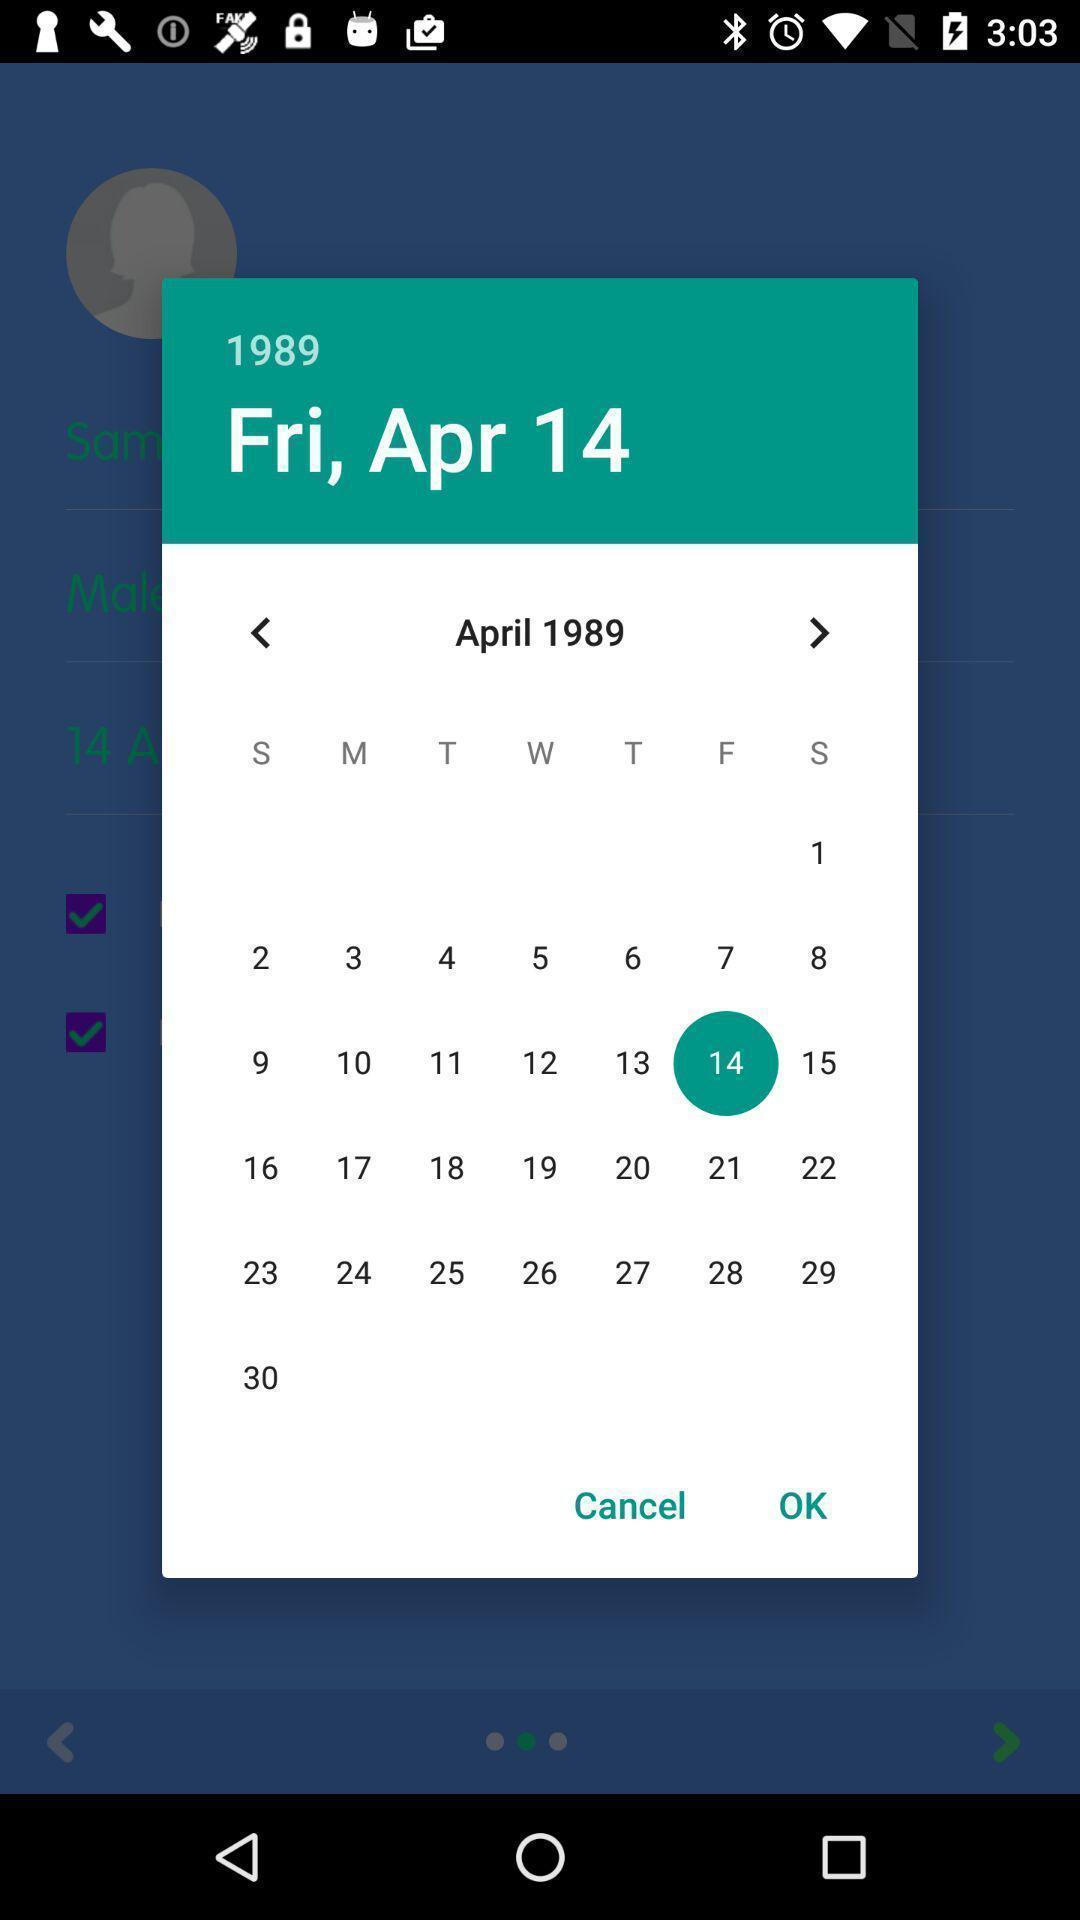What is the overall content of this screenshot? Pop-up showing the date in a calender. 